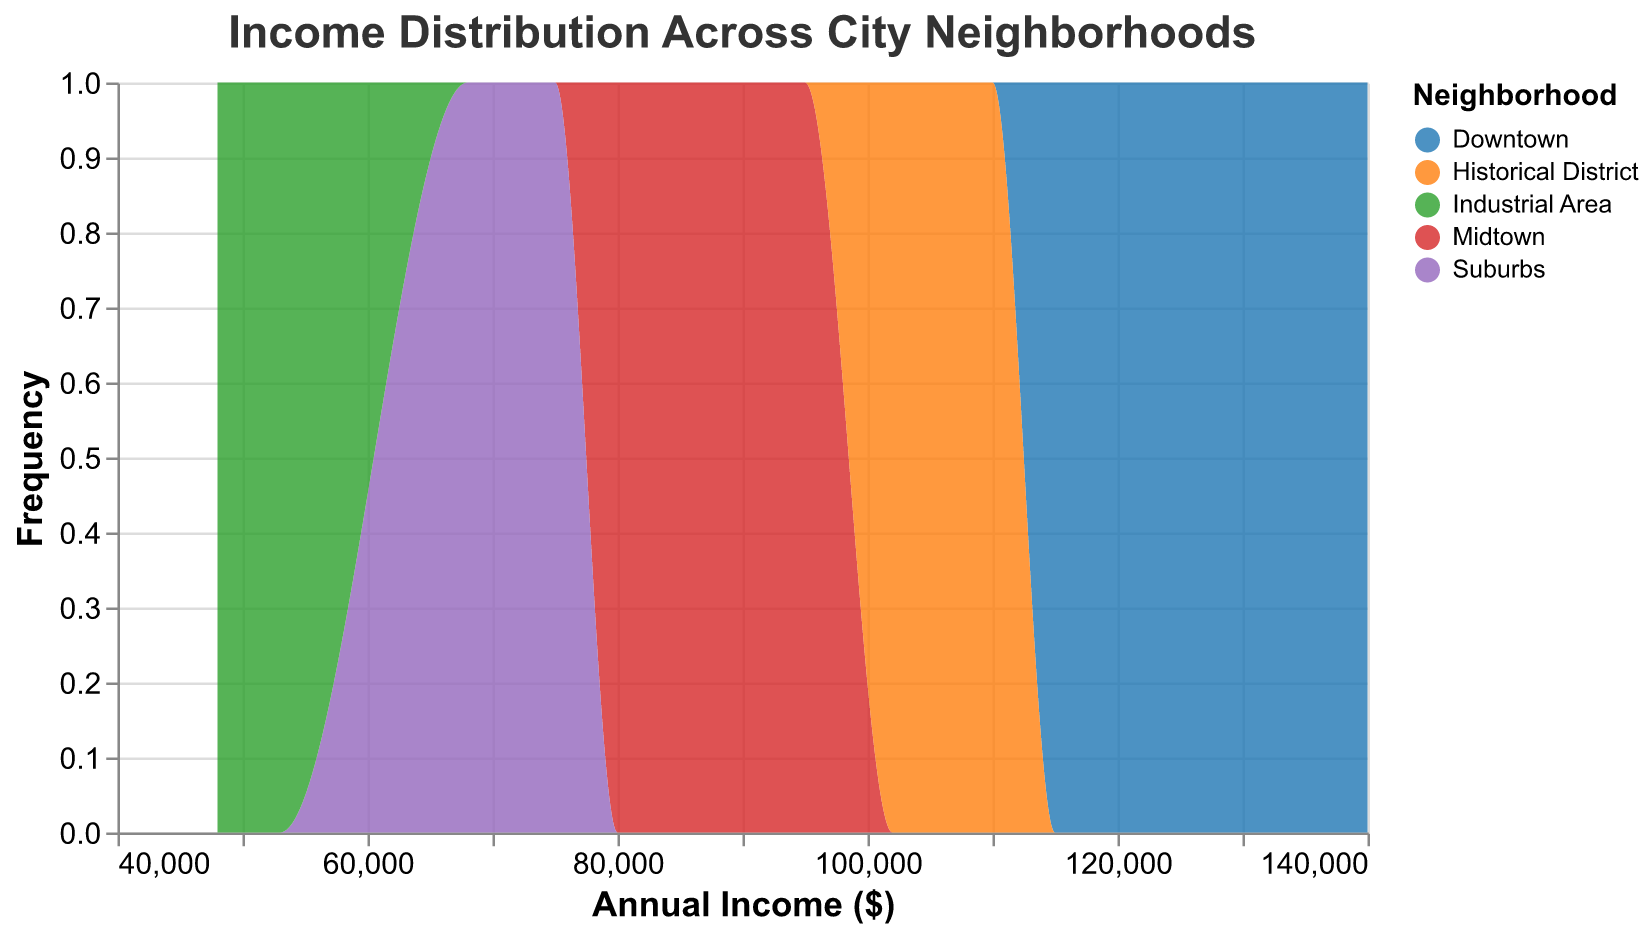What is the title of the plot? The title of the plot is prominently displayed at the top and reads "Income Distribution Across City Neighborhoods".
Answer: Income Distribution Across City Neighborhoods What does the x-axis represent? The x-axis, as labeled in the plot, represents the "Annual Income ($)". It shows the range of different annual incomes in dollars.
Answer: Annual Income ($) Which neighborhood has the highest peak in frequency? By analyzing the frequency on the y-axis in relation to the color-coded neighborhoods, Downtown has the highest peak in frequency.
Answer: Downtown What is the range of income for the Industrial Area? The income range for the Industrial Area can be observed from the plot by looking at the colored areas corresponding to it. The range spans from $48,000 to $53,000.
Answer: $48,000 to $53,000 Which neighborhood has the smallest spread of income? To find the neighborhood with the smallest spread, we look at the width of the distribution for each color-coded segment. The Industrial Area has the smallest spread as it ranges only slightly from $48,000 to $53,000.
Answer: Industrial Area What neighborhoods have incomes that overlap around $90,000? By inspecting the plot, the income around $90,000 overlaps between Midtown and Historical District.
Answer: Midtown and Historical District How many distinct income values are there for the Suburbs? The Suburbs have distinct income values shown as different peaks or spread along the x-axis. By counting the visual representation, there are five distinct income values: $68,000, $69,000, $70,000, $72,000, and $75,000.
Answer: 5 Which neighborhood has the highest income? Checking the far-right end of the x-axis and identifying the color-coded area closest to that value, Downtown has the highest income of $140,000.
Answer: Downtown What is the approximate median income for the Historical District? The median income for the Historical District would fall in the middle of the income range visually represented by its color. The graph shows that this appears to be around $108,000.
Answer: $108,000 